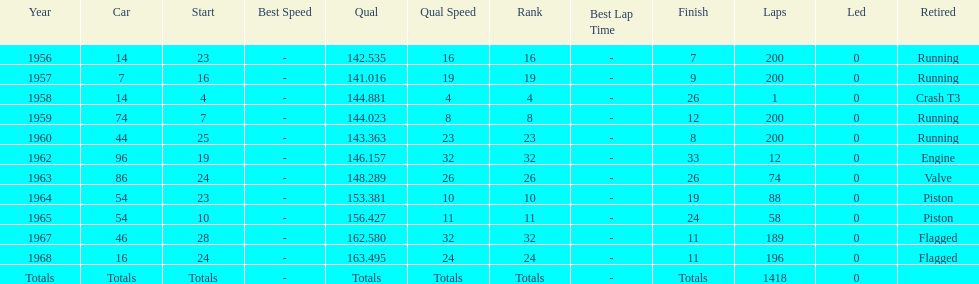How many times did he finish all 200 laps? 4. 